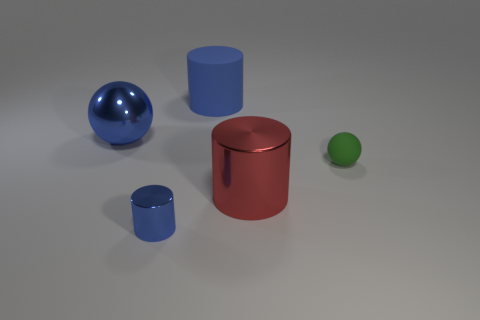Add 5 rubber objects. How many objects exist? 10 Subtract all cylinders. How many objects are left? 2 Subtract 1 blue spheres. How many objects are left? 4 Subtract all small green matte balls. Subtract all large red cylinders. How many objects are left? 3 Add 3 big blue cylinders. How many big blue cylinders are left? 4 Add 3 large spheres. How many large spheres exist? 4 